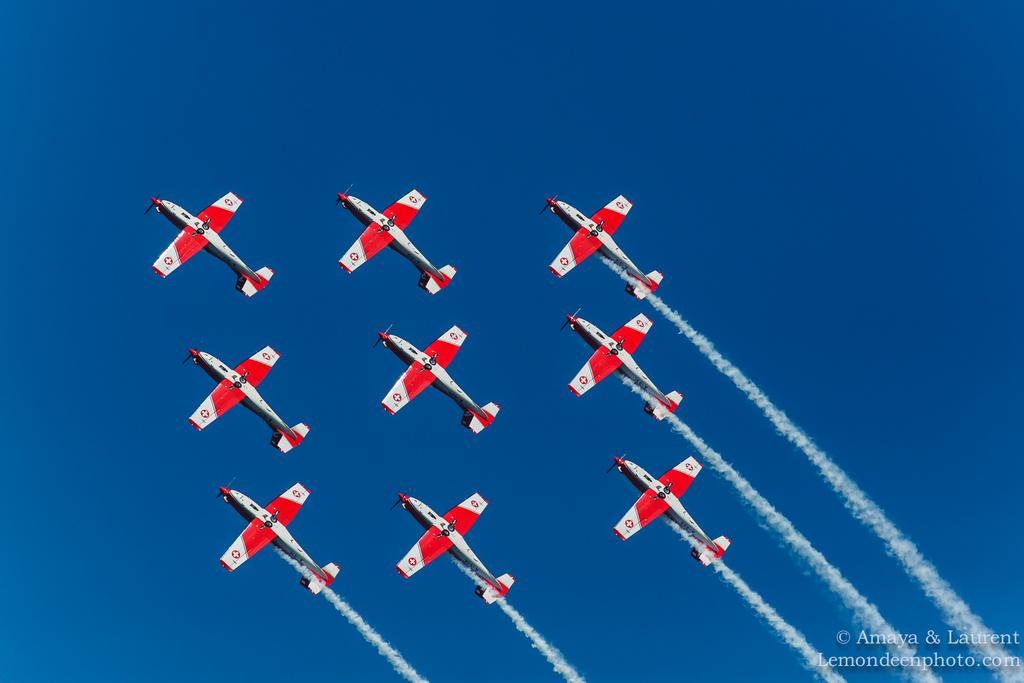What is the main subject of the image? The main subject of the image is many aircrafts. Can you describe the smoke visible in the image? There is smoke visible on the right side of the image. What is present in the bottom right corner of the image? There is text in the bottom right corner of the image. What can be seen behind the aircraft in the image? The sky is visible behind the aircraft. How many chances does the cemetery have to be seen in the image? There is no cemetery present in the image, so it cannot be seen. 